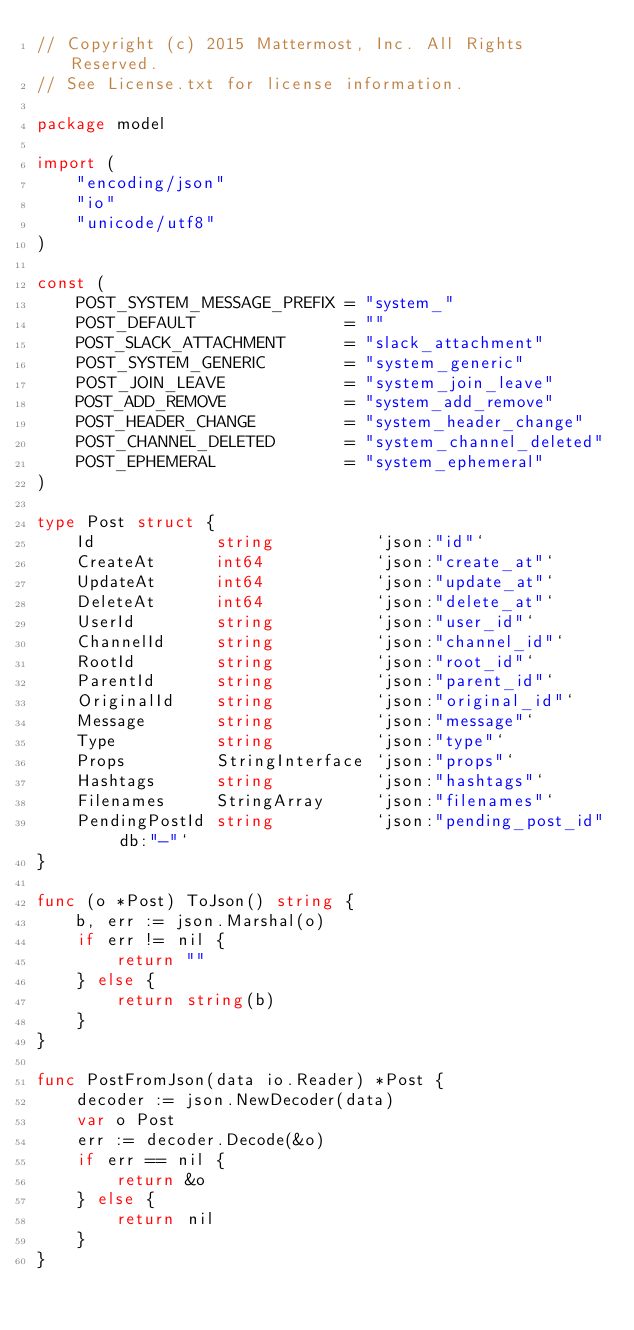<code> <loc_0><loc_0><loc_500><loc_500><_Go_>// Copyright (c) 2015 Mattermost, Inc. All Rights Reserved.
// See License.txt for license information.

package model

import (
	"encoding/json"
	"io"
	"unicode/utf8"
)

const (
	POST_SYSTEM_MESSAGE_PREFIX = "system_"
	POST_DEFAULT               = ""
	POST_SLACK_ATTACHMENT      = "slack_attachment"
	POST_SYSTEM_GENERIC        = "system_generic"
	POST_JOIN_LEAVE            = "system_join_leave"
	POST_ADD_REMOVE            = "system_add_remove"
	POST_HEADER_CHANGE         = "system_header_change"
	POST_CHANNEL_DELETED       = "system_channel_deleted"
	POST_EPHEMERAL             = "system_ephemeral"
)

type Post struct {
	Id            string          `json:"id"`
	CreateAt      int64           `json:"create_at"`
	UpdateAt      int64           `json:"update_at"`
	DeleteAt      int64           `json:"delete_at"`
	UserId        string          `json:"user_id"`
	ChannelId     string          `json:"channel_id"`
	RootId        string          `json:"root_id"`
	ParentId      string          `json:"parent_id"`
	OriginalId    string          `json:"original_id"`
	Message       string          `json:"message"`
	Type          string          `json:"type"`
	Props         StringInterface `json:"props"`
	Hashtags      string          `json:"hashtags"`
	Filenames     StringArray     `json:"filenames"`
	PendingPostId string          `json:"pending_post_id" db:"-"`
}

func (o *Post) ToJson() string {
	b, err := json.Marshal(o)
	if err != nil {
		return ""
	} else {
		return string(b)
	}
}

func PostFromJson(data io.Reader) *Post {
	decoder := json.NewDecoder(data)
	var o Post
	err := decoder.Decode(&o)
	if err == nil {
		return &o
	} else {
		return nil
	}
}
</code> 